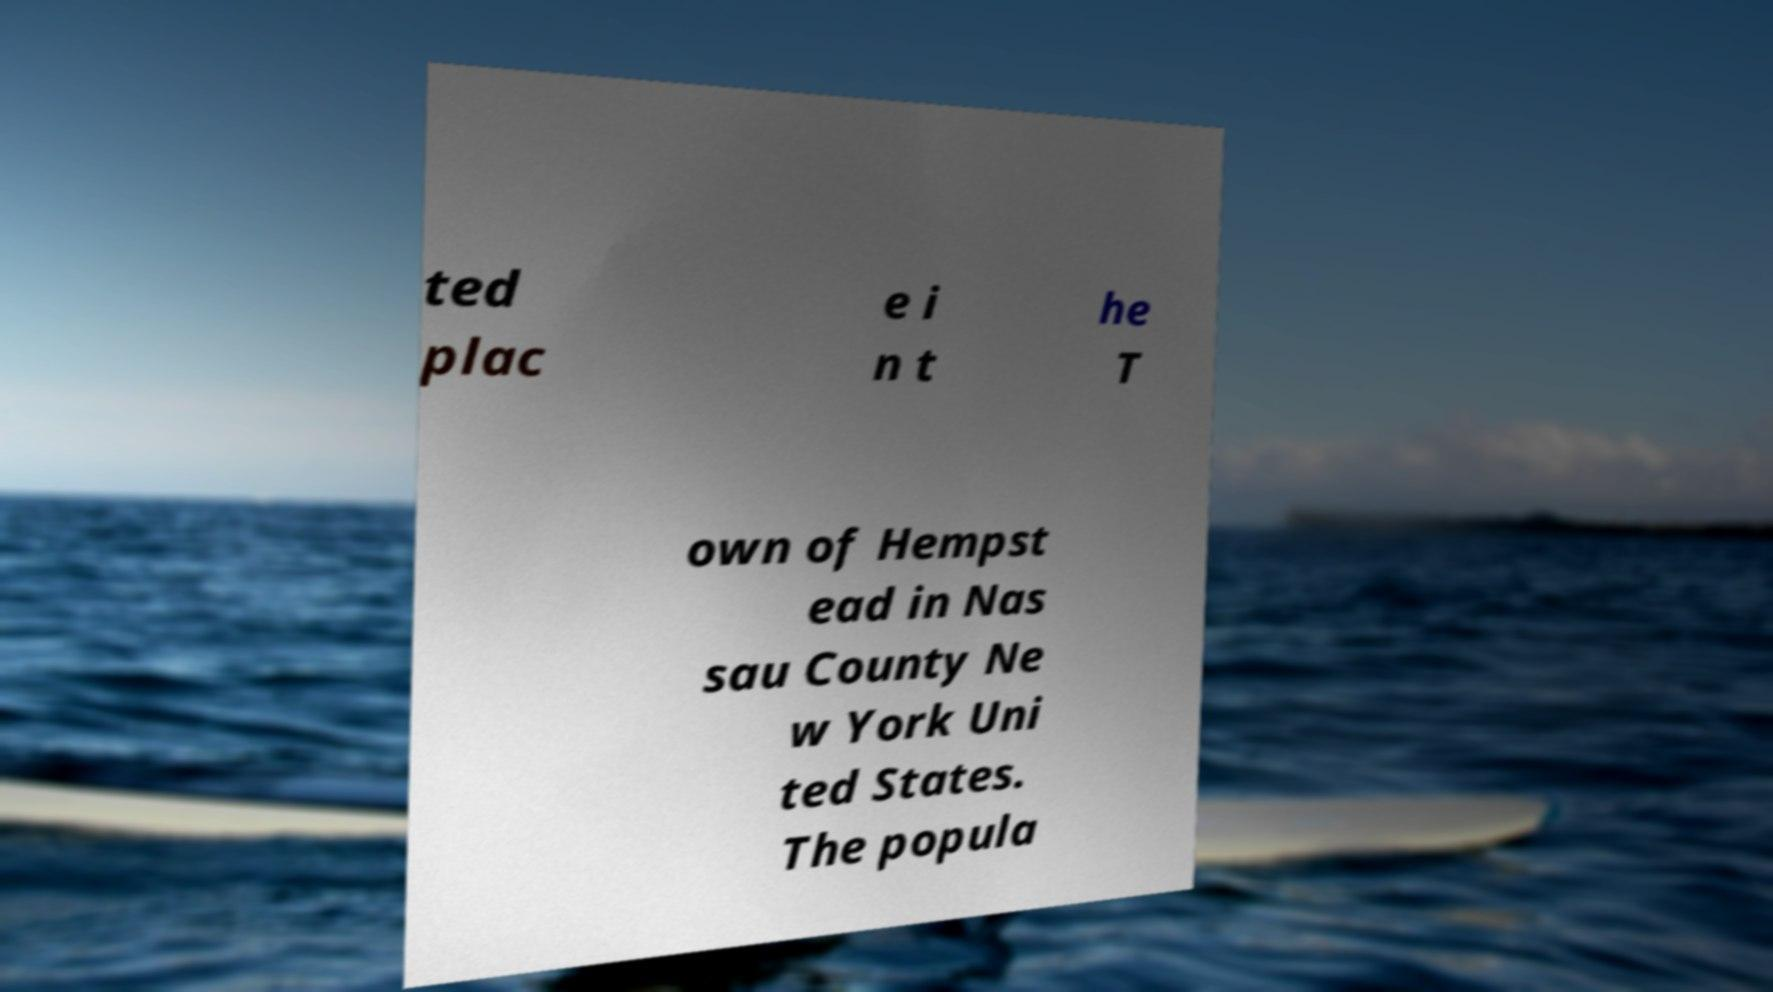Can you accurately transcribe the text from the provided image for me? ted plac e i n t he T own of Hempst ead in Nas sau County Ne w York Uni ted States. The popula 